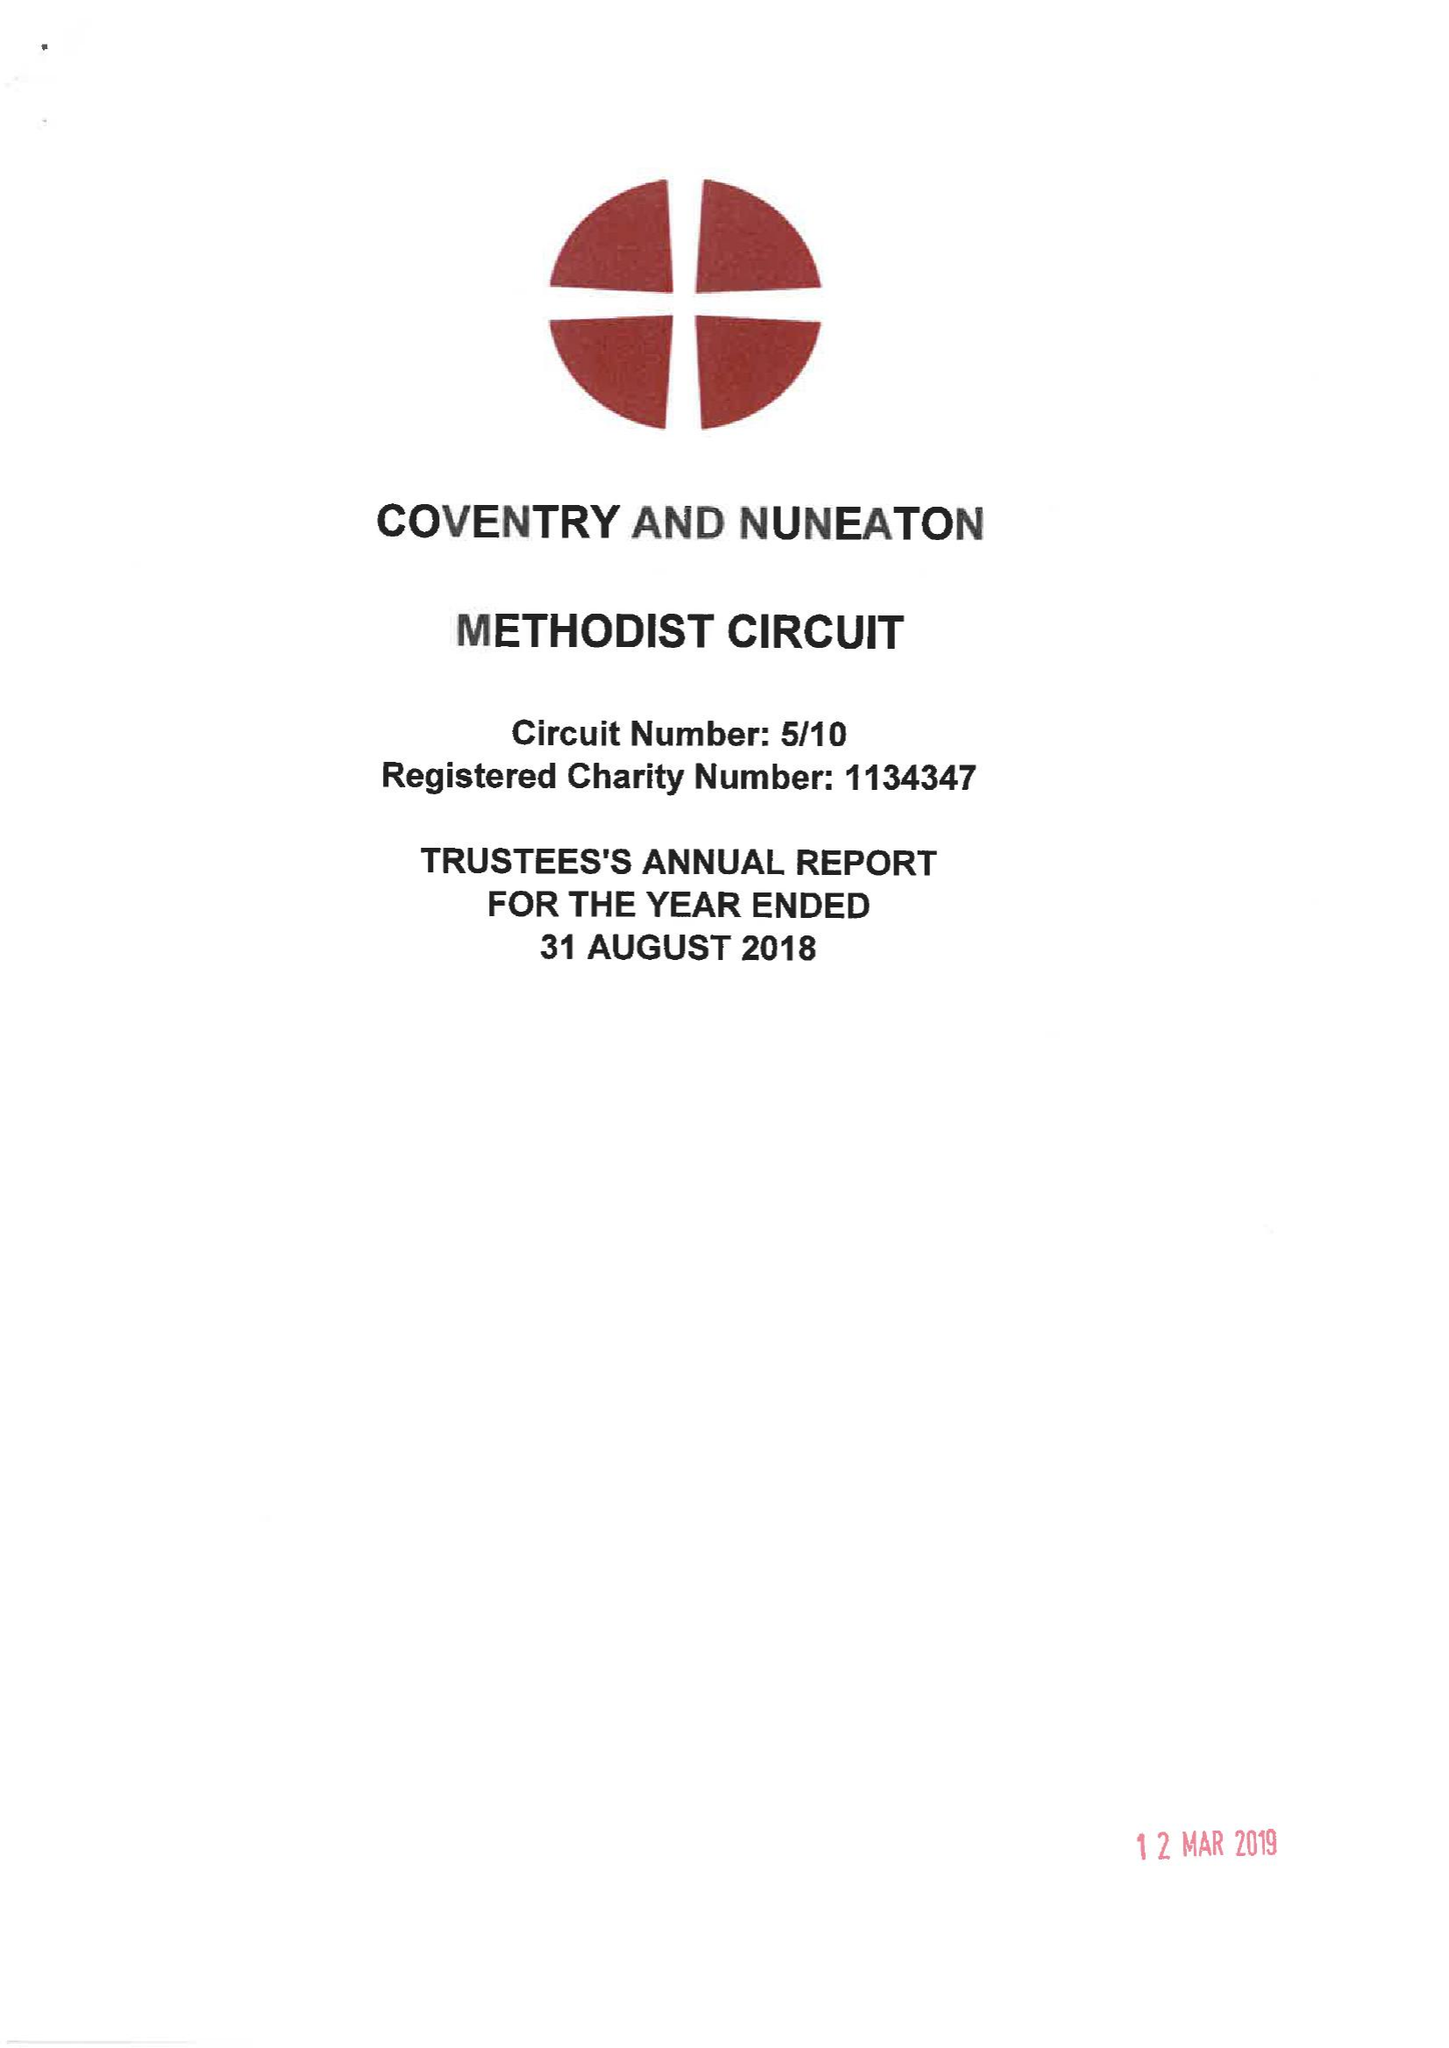What is the value for the address__street_line?
Answer the question using a single word or phrase. WARWICK LANE 